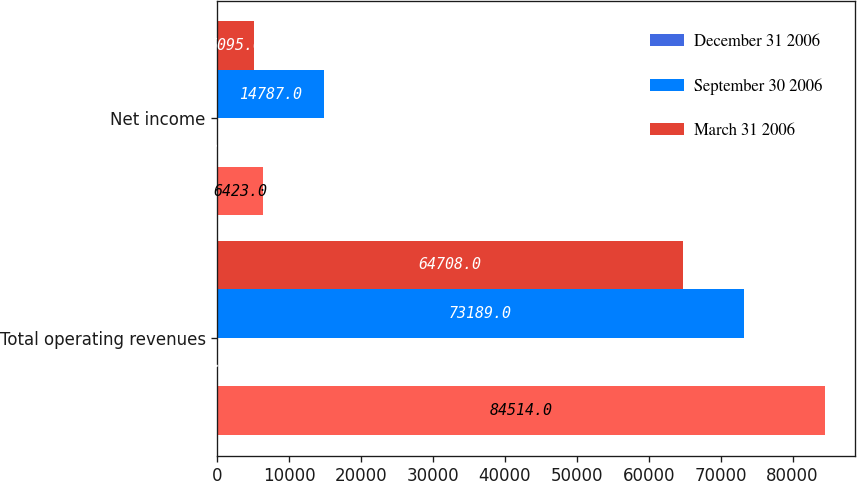Convert chart. <chart><loc_0><loc_0><loc_500><loc_500><stacked_bar_chart><ecel><fcel>Total operating revenues<fcel>Net income<nl><fcel>nan<fcel>84514<fcel>6423<nl><fcel>December 31 2006<fcel>1<fcel>2<nl><fcel>September 30 2006<fcel>73189<fcel>14787<nl><fcel>March 31 2006<fcel>64708<fcel>5095<nl></chart> 